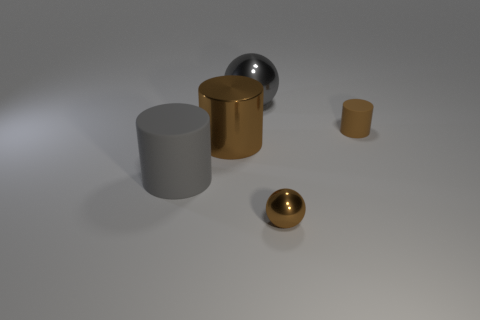Does the gray object that is behind the brown rubber cylinder have the same size as the small rubber thing?
Offer a very short reply. No. Are there an equal number of large cylinders that are on the left side of the brown metal cylinder and gray metal objects?
Your answer should be compact. Yes. What number of objects are either tiny brown things that are behind the large rubber cylinder or gray cylinders?
Offer a terse response. 2. There is a brown object that is behind the big rubber cylinder and on the right side of the big gray sphere; what shape is it?
Your answer should be very brief. Cylinder. How many objects are brown metal things to the left of the small brown metal ball or objects that are to the right of the gray rubber cylinder?
Your response must be concise. 4. How many other objects are the same size as the gray shiny thing?
Your answer should be very brief. 2. There is a large object that is behind the small cylinder; is its color the same as the tiny rubber cylinder?
Offer a very short reply. No. There is a cylinder that is to the left of the tiny metallic object and right of the big gray rubber cylinder; how big is it?
Your response must be concise. Large. What number of large things are gray objects or red matte things?
Give a very brief answer. 2. There is a big thing on the left side of the big brown cylinder; what is its shape?
Ensure brevity in your answer.  Cylinder. 